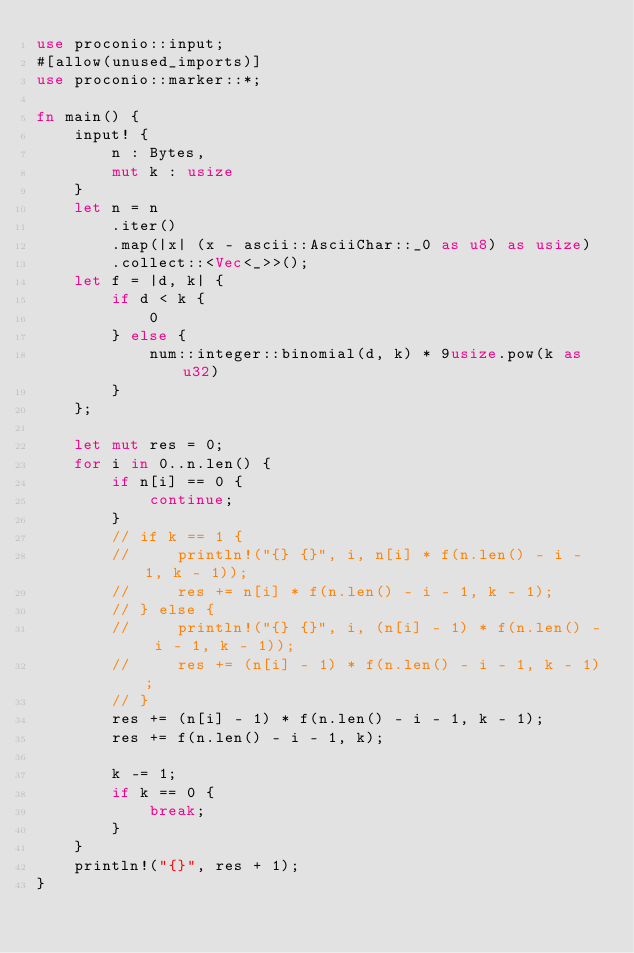<code> <loc_0><loc_0><loc_500><loc_500><_Rust_>use proconio::input;
#[allow(unused_imports)]
use proconio::marker::*;

fn main() {
    input! {
        n : Bytes,
        mut k : usize
    }
    let n = n
        .iter()
        .map(|x| (x - ascii::AsciiChar::_0 as u8) as usize)
        .collect::<Vec<_>>();
    let f = |d, k| {
        if d < k {
            0
        } else {
            num::integer::binomial(d, k) * 9usize.pow(k as u32)
        }
    };

    let mut res = 0;
    for i in 0..n.len() {
        if n[i] == 0 {
            continue;
        }
        // if k == 1 {
        //     println!("{} {}", i, n[i] * f(n.len() - i - 1, k - 1));
        //     res += n[i] * f(n.len() - i - 1, k - 1);
        // } else {
        //     println!("{} {}", i, (n[i] - 1) * f(n.len() - i - 1, k - 1));
        //     res += (n[i] - 1) * f(n.len() - i - 1, k - 1);
        // }
        res += (n[i] - 1) * f(n.len() - i - 1, k - 1);
        res += f(n.len() - i - 1, k);

        k -= 1;
        if k == 0 {
            break;
        }
    }
    println!("{}", res + 1);
}
</code> 